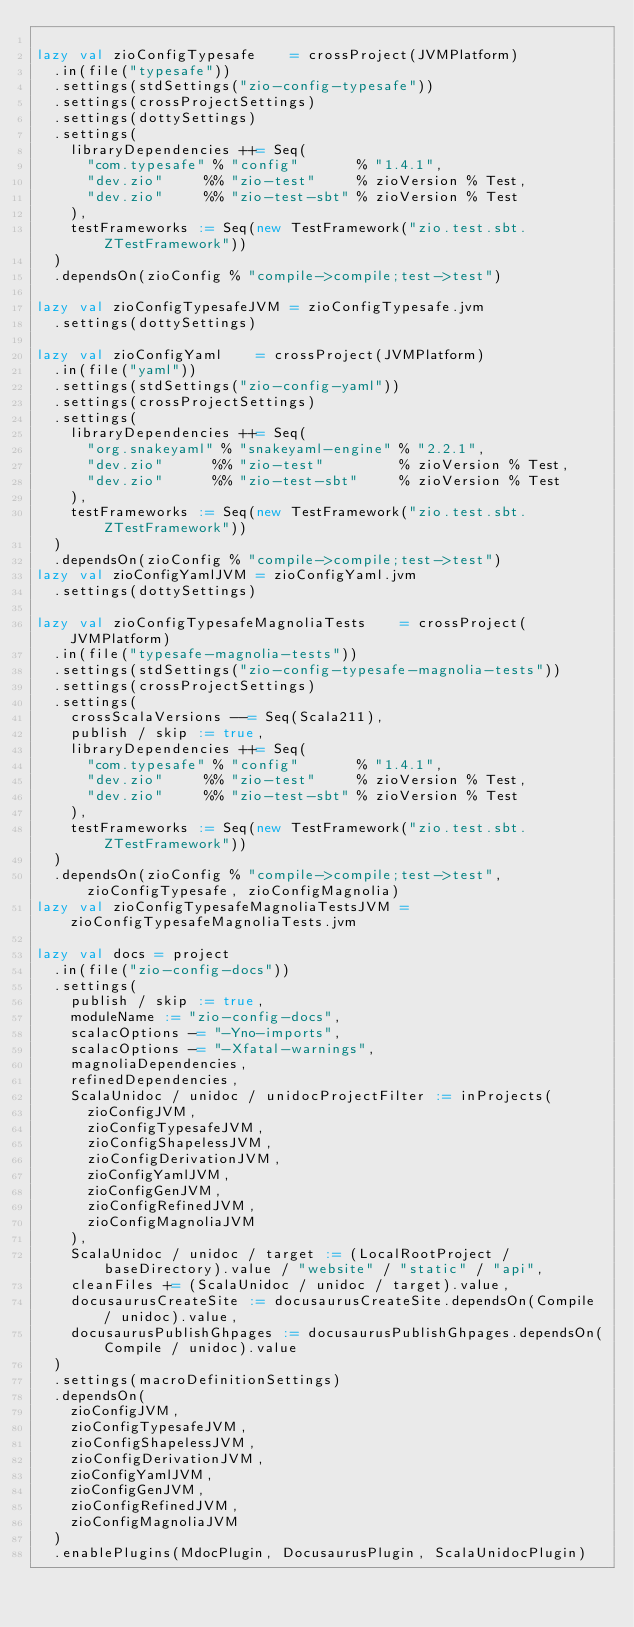<code> <loc_0><loc_0><loc_500><loc_500><_Scala_>
lazy val zioConfigTypesafe    = crossProject(JVMPlatform)
  .in(file("typesafe"))
  .settings(stdSettings("zio-config-typesafe"))
  .settings(crossProjectSettings)
  .settings(dottySettings)
  .settings(
    libraryDependencies ++= Seq(
      "com.typesafe" % "config"       % "1.4.1",
      "dev.zio"     %% "zio-test"     % zioVersion % Test,
      "dev.zio"     %% "zio-test-sbt" % zioVersion % Test
    ),
    testFrameworks := Seq(new TestFramework("zio.test.sbt.ZTestFramework"))
  )
  .dependsOn(zioConfig % "compile->compile;test->test")

lazy val zioConfigTypesafeJVM = zioConfigTypesafe.jvm
  .settings(dottySettings)

lazy val zioConfigYaml    = crossProject(JVMPlatform)
  .in(file("yaml"))
  .settings(stdSettings("zio-config-yaml"))
  .settings(crossProjectSettings)
  .settings(
    libraryDependencies ++= Seq(
      "org.snakeyaml" % "snakeyaml-engine" % "2.2.1",
      "dev.zio"      %% "zio-test"         % zioVersion % Test,
      "dev.zio"      %% "zio-test-sbt"     % zioVersion % Test
    ),
    testFrameworks := Seq(new TestFramework("zio.test.sbt.ZTestFramework"))
  )
  .dependsOn(zioConfig % "compile->compile;test->test")
lazy val zioConfigYamlJVM = zioConfigYaml.jvm
  .settings(dottySettings)

lazy val zioConfigTypesafeMagnoliaTests    = crossProject(JVMPlatform)
  .in(file("typesafe-magnolia-tests"))
  .settings(stdSettings("zio-config-typesafe-magnolia-tests"))
  .settings(crossProjectSettings)
  .settings(
    crossScalaVersions --= Seq(Scala211),
    publish / skip := true,
    libraryDependencies ++= Seq(
      "com.typesafe" % "config"       % "1.4.1",
      "dev.zio"     %% "zio-test"     % zioVersion % Test,
      "dev.zio"     %% "zio-test-sbt" % zioVersion % Test
    ),
    testFrameworks := Seq(new TestFramework("zio.test.sbt.ZTestFramework"))
  )
  .dependsOn(zioConfig % "compile->compile;test->test", zioConfigTypesafe, zioConfigMagnolia)
lazy val zioConfigTypesafeMagnoliaTestsJVM = zioConfigTypesafeMagnoliaTests.jvm

lazy val docs = project
  .in(file("zio-config-docs"))
  .settings(
    publish / skip := true,
    moduleName := "zio-config-docs",
    scalacOptions -= "-Yno-imports",
    scalacOptions -= "-Xfatal-warnings",
    magnoliaDependencies,
    refinedDependencies,
    ScalaUnidoc / unidoc / unidocProjectFilter := inProjects(
      zioConfigJVM,
      zioConfigTypesafeJVM,
      zioConfigShapelessJVM,
      zioConfigDerivationJVM,
      zioConfigYamlJVM,
      zioConfigGenJVM,
      zioConfigRefinedJVM,
      zioConfigMagnoliaJVM
    ),
    ScalaUnidoc / unidoc / target := (LocalRootProject / baseDirectory).value / "website" / "static" / "api",
    cleanFiles += (ScalaUnidoc / unidoc / target).value,
    docusaurusCreateSite := docusaurusCreateSite.dependsOn(Compile / unidoc).value,
    docusaurusPublishGhpages := docusaurusPublishGhpages.dependsOn(Compile / unidoc).value
  )
  .settings(macroDefinitionSettings)
  .dependsOn(
    zioConfigJVM,
    zioConfigTypesafeJVM,
    zioConfigShapelessJVM,
    zioConfigDerivationJVM,
    zioConfigYamlJVM,
    zioConfigGenJVM,
    zioConfigRefinedJVM,
    zioConfigMagnoliaJVM
  )
  .enablePlugins(MdocPlugin, DocusaurusPlugin, ScalaUnidocPlugin)
</code> 